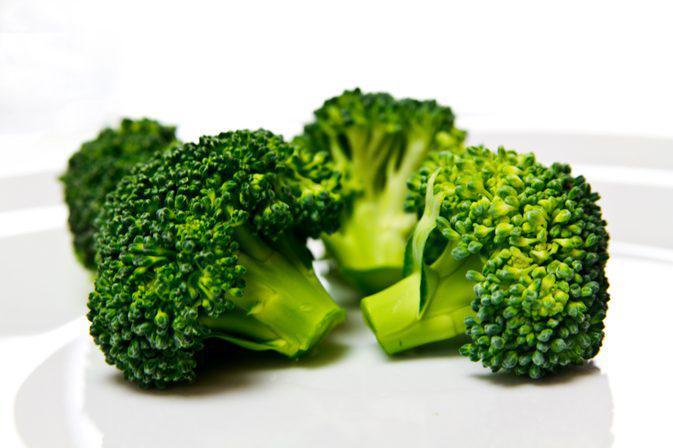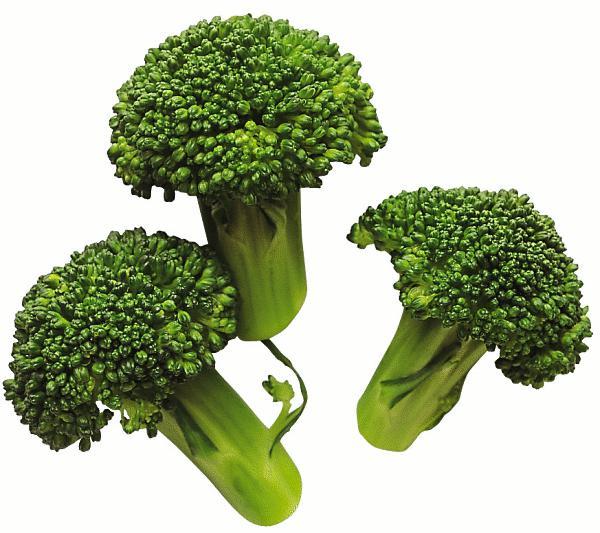The first image is the image on the left, the second image is the image on the right. Examine the images to the left and right. Is the description "No image contains more than five cut pieces of broccoli." accurate? Answer yes or no. Yes. The first image is the image on the left, the second image is the image on the right. Given the left and right images, does the statement "The broccoli on the right is a brighter green than on the left." hold true? Answer yes or no. No. 